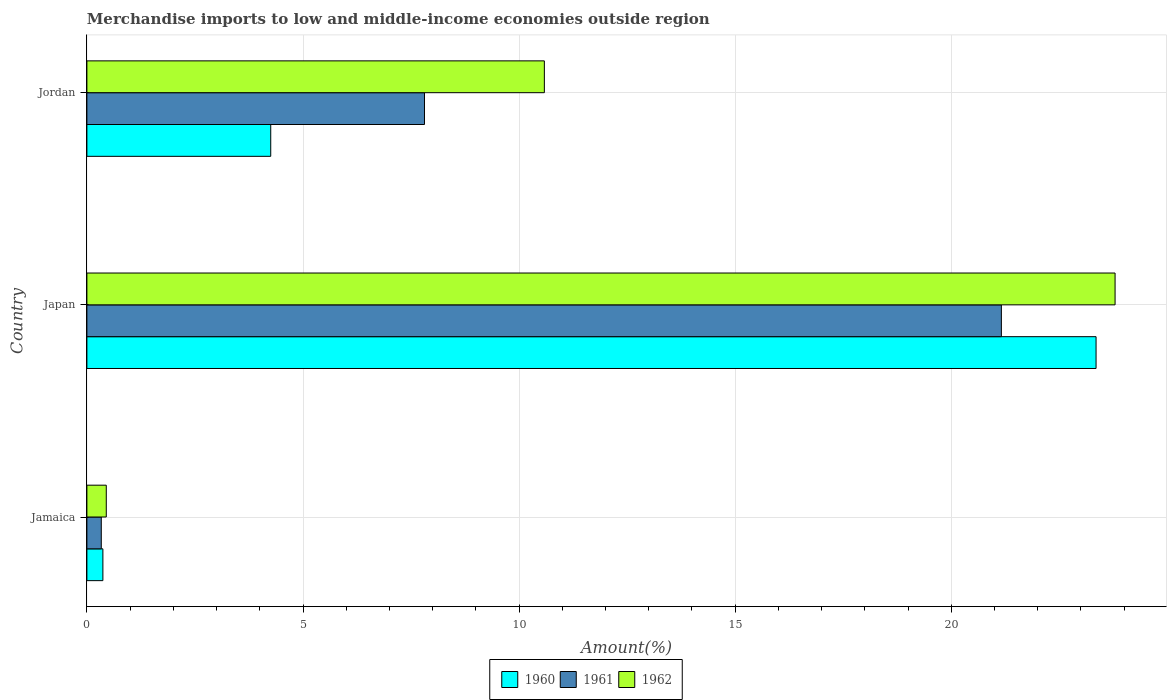How many different coloured bars are there?
Make the answer very short. 3. How many groups of bars are there?
Keep it short and to the point. 3. Are the number of bars per tick equal to the number of legend labels?
Your answer should be very brief. Yes. Are the number of bars on each tick of the Y-axis equal?
Offer a terse response. Yes. How many bars are there on the 1st tick from the top?
Ensure brevity in your answer.  3. How many bars are there on the 2nd tick from the bottom?
Offer a very short reply. 3. What is the label of the 1st group of bars from the top?
Give a very brief answer. Jordan. In how many cases, is the number of bars for a given country not equal to the number of legend labels?
Your answer should be very brief. 0. What is the percentage of amount earned from merchandise imports in 1962 in Jordan?
Give a very brief answer. 10.58. Across all countries, what is the maximum percentage of amount earned from merchandise imports in 1962?
Provide a succinct answer. 23.79. Across all countries, what is the minimum percentage of amount earned from merchandise imports in 1962?
Keep it short and to the point. 0.45. In which country was the percentage of amount earned from merchandise imports in 1962 minimum?
Make the answer very short. Jamaica. What is the total percentage of amount earned from merchandise imports in 1962 in the graph?
Your response must be concise. 34.82. What is the difference between the percentage of amount earned from merchandise imports in 1962 in Jamaica and that in Japan?
Make the answer very short. -23.34. What is the difference between the percentage of amount earned from merchandise imports in 1960 in Japan and the percentage of amount earned from merchandise imports in 1961 in Jordan?
Offer a very short reply. 15.54. What is the average percentage of amount earned from merchandise imports in 1961 per country?
Give a very brief answer. 9.77. What is the difference between the percentage of amount earned from merchandise imports in 1961 and percentage of amount earned from merchandise imports in 1962 in Japan?
Your answer should be compact. -2.63. What is the ratio of the percentage of amount earned from merchandise imports in 1962 in Jamaica to that in Japan?
Offer a terse response. 0.02. Is the difference between the percentage of amount earned from merchandise imports in 1961 in Jamaica and Japan greater than the difference between the percentage of amount earned from merchandise imports in 1962 in Jamaica and Japan?
Offer a terse response. Yes. What is the difference between the highest and the second highest percentage of amount earned from merchandise imports in 1960?
Provide a short and direct response. 19.1. What is the difference between the highest and the lowest percentage of amount earned from merchandise imports in 1960?
Your response must be concise. 22.98. What does the 3rd bar from the top in Jamaica represents?
Your answer should be very brief. 1960. What is the difference between two consecutive major ticks on the X-axis?
Offer a terse response. 5. Are the values on the major ticks of X-axis written in scientific E-notation?
Your response must be concise. No. Where does the legend appear in the graph?
Offer a very short reply. Bottom center. How many legend labels are there?
Give a very brief answer. 3. How are the legend labels stacked?
Offer a terse response. Horizontal. What is the title of the graph?
Your response must be concise. Merchandise imports to low and middle-income economies outside region. What is the label or title of the X-axis?
Provide a short and direct response. Amount(%). What is the label or title of the Y-axis?
Keep it short and to the point. Country. What is the Amount(%) in 1960 in Jamaica?
Your response must be concise. 0.37. What is the Amount(%) of 1961 in Jamaica?
Your response must be concise. 0.33. What is the Amount(%) of 1962 in Jamaica?
Offer a terse response. 0.45. What is the Amount(%) in 1960 in Japan?
Provide a short and direct response. 23.35. What is the Amount(%) in 1961 in Japan?
Provide a short and direct response. 21.16. What is the Amount(%) of 1962 in Japan?
Your answer should be compact. 23.79. What is the Amount(%) of 1960 in Jordan?
Give a very brief answer. 4.25. What is the Amount(%) in 1961 in Jordan?
Your response must be concise. 7.81. What is the Amount(%) of 1962 in Jordan?
Offer a terse response. 10.58. Across all countries, what is the maximum Amount(%) of 1960?
Your response must be concise. 23.35. Across all countries, what is the maximum Amount(%) of 1961?
Provide a succinct answer. 21.16. Across all countries, what is the maximum Amount(%) of 1962?
Ensure brevity in your answer.  23.79. Across all countries, what is the minimum Amount(%) in 1960?
Offer a very short reply. 0.37. Across all countries, what is the minimum Amount(%) of 1961?
Your answer should be compact. 0.33. Across all countries, what is the minimum Amount(%) in 1962?
Your answer should be compact. 0.45. What is the total Amount(%) of 1960 in the graph?
Provide a short and direct response. 27.97. What is the total Amount(%) in 1961 in the graph?
Offer a terse response. 29.3. What is the total Amount(%) of 1962 in the graph?
Your response must be concise. 34.82. What is the difference between the Amount(%) of 1960 in Jamaica and that in Japan?
Give a very brief answer. -22.98. What is the difference between the Amount(%) of 1961 in Jamaica and that in Japan?
Keep it short and to the point. -20.83. What is the difference between the Amount(%) of 1962 in Jamaica and that in Japan?
Ensure brevity in your answer.  -23.34. What is the difference between the Amount(%) in 1960 in Jamaica and that in Jordan?
Ensure brevity in your answer.  -3.88. What is the difference between the Amount(%) in 1961 in Jamaica and that in Jordan?
Your response must be concise. -7.48. What is the difference between the Amount(%) in 1962 in Jamaica and that in Jordan?
Give a very brief answer. -10.14. What is the difference between the Amount(%) in 1960 in Japan and that in Jordan?
Provide a succinct answer. 19.1. What is the difference between the Amount(%) of 1961 in Japan and that in Jordan?
Provide a short and direct response. 13.35. What is the difference between the Amount(%) in 1962 in Japan and that in Jordan?
Give a very brief answer. 13.21. What is the difference between the Amount(%) of 1960 in Jamaica and the Amount(%) of 1961 in Japan?
Offer a terse response. -20.79. What is the difference between the Amount(%) in 1960 in Jamaica and the Amount(%) in 1962 in Japan?
Offer a terse response. -23.42. What is the difference between the Amount(%) in 1961 in Jamaica and the Amount(%) in 1962 in Japan?
Your response must be concise. -23.46. What is the difference between the Amount(%) in 1960 in Jamaica and the Amount(%) in 1961 in Jordan?
Offer a very short reply. -7.44. What is the difference between the Amount(%) in 1960 in Jamaica and the Amount(%) in 1962 in Jordan?
Provide a succinct answer. -10.21. What is the difference between the Amount(%) of 1961 in Jamaica and the Amount(%) of 1962 in Jordan?
Offer a terse response. -10.25. What is the difference between the Amount(%) of 1960 in Japan and the Amount(%) of 1961 in Jordan?
Offer a very short reply. 15.54. What is the difference between the Amount(%) of 1960 in Japan and the Amount(%) of 1962 in Jordan?
Give a very brief answer. 12.77. What is the difference between the Amount(%) in 1961 in Japan and the Amount(%) in 1962 in Jordan?
Give a very brief answer. 10.57. What is the average Amount(%) of 1960 per country?
Your answer should be very brief. 9.32. What is the average Amount(%) of 1961 per country?
Ensure brevity in your answer.  9.77. What is the average Amount(%) of 1962 per country?
Your answer should be very brief. 11.61. What is the difference between the Amount(%) of 1960 and Amount(%) of 1961 in Jamaica?
Provide a succinct answer. 0.04. What is the difference between the Amount(%) in 1960 and Amount(%) in 1962 in Jamaica?
Your answer should be compact. -0.08. What is the difference between the Amount(%) in 1961 and Amount(%) in 1962 in Jamaica?
Provide a short and direct response. -0.12. What is the difference between the Amount(%) in 1960 and Amount(%) in 1961 in Japan?
Offer a terse response. 2.19. What is the difference between the Amount(%) of 1960 and Amount(%) of 1962 in Japan?
Make the answer very short. -0.44. What is the difference between the Amount(%) of 1961 and Amount(%) of 1962 in Japan?
Your answer should be compact. -2.63. What is the difference between the Amount(%) of 1960 and Amount(%) of 1961 in Jordan?
Give a very brief answer. -3.56. What is the difference between the Amount(%) of 1960 and Amount(%) of 1962 in Jordan?
Provide a short and direct response. -6.33. What is the difference between the Amount(%) of 1961 and Amount(%) of 1962 in Jordan?
Provide a short and direct response. -2.77. What is the ratio of the Amount(%) of 1960 in Jamaica to that in Japan?
Provide a succinct answer. 0.02. What is the ratio of the Amount(%) of 1961 in Jamaica to that in Japan?
Make the answer very short. 0.02. What is the ratio of the Amount(%) in 1962 in Jamaica to that in Japan?
Provide a succinct answer. 0.02. What is the ratio of the Amount(%) of 1960 in Jamaica to that in Jordan?
Your answer should be very brief. 0.09. What is the ratio of the Amount(%) in 1961 in Jamaica to that in Jordan?
Offer a terse response. 0.04. What is the ratio of the Amount(%) of 1962 in Jamaica to that in Jordan?
Your answer should be compact. 0.04. What is the ratio of the Amount(%) in 1960 in Japan to that in Jordan?
Your answer should be very brief. 5.49. What is the ratio of the Amount(%) of 1961 in Japan to that in Jordan?
Keep it short and to the point. 2.71. What is the ratio of the Amount(%) of 1962 in Japan to that in Jordan?
Your response must be concise. 2.25. What is the difference between the highest and the second highest Amount(%) in 1960?
Make the answer very short. 19.1. What is the difference between the highest and the second highest Amount(%) in 1961?
Keep it short and to the point. 13.35. What is the difference between the highest and the second highest Amount(%) of 1962?
Keep it short and to the point. 13.21. What is the difference between the highest and the lowest Amount(%) in 1960?
Keep it short and to the point. 22.98. What is the difference between the highest and the lowest Amount(%) in 1961?
Keep it short and to the point. 20.83. What is the difference between the highest and the lowest Amount(%) of 1962?
Give a very brief answer. 23.34. 